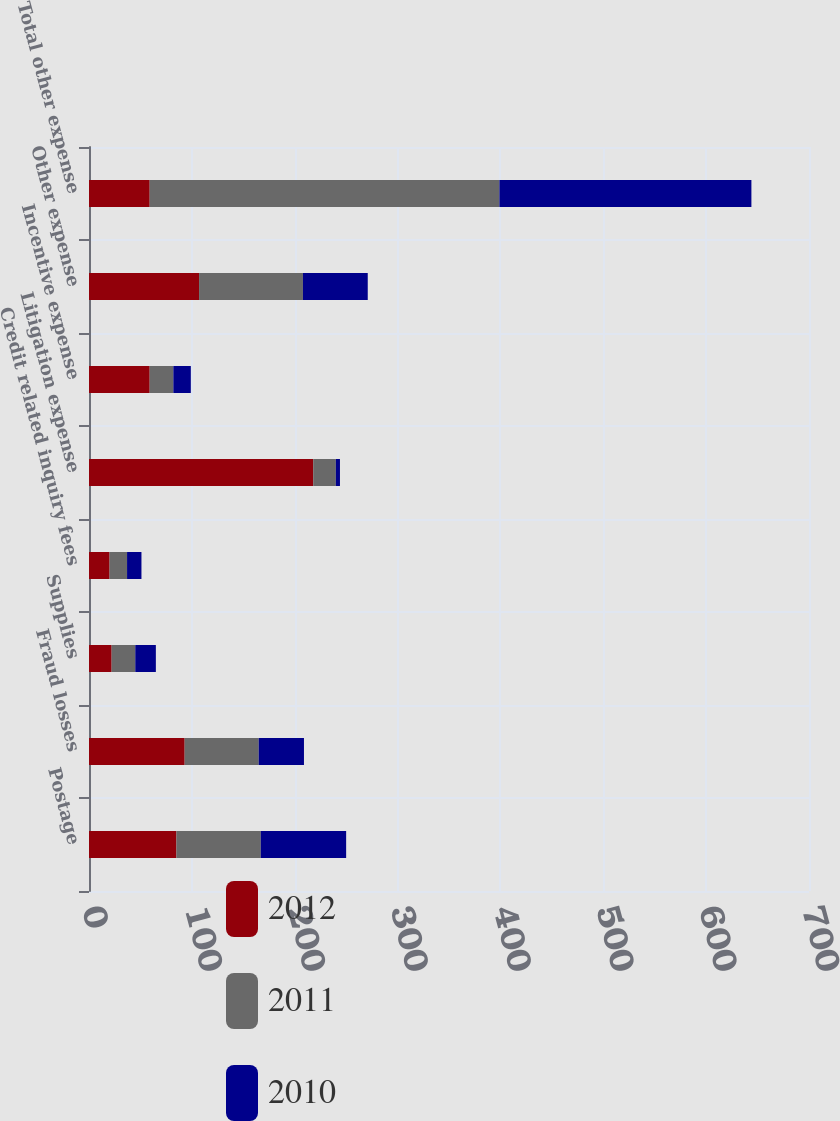<chart> <loc_0><loc_0><loc_500><loc_500><stacked_bar_chart><ecel><fcel>Postage<fcel>Fraud losses<fcel>Supplies<fcel>Credit related inquiry fees<fcel>Litigation expense<fcel>Incentive expense<fcel>Other expense<fcel>Total other expense<nl><fcel>2012<fcel>85<fcel>93<fcel>22<fcel>20<fcel>218<fcel>59<fcel>107<fcel>59<nl><fcel>2011<fcel>82<fcel>72<fcel>23<fcel>17<fcel>22<fcel>23<fcel>101<fcel>340<nl><fcel>2010<fcel>83<fcel>44<fcel>20<fcel>14<fcel>4<fcel>17<fcel>63<fcel>245<nl></chart> 